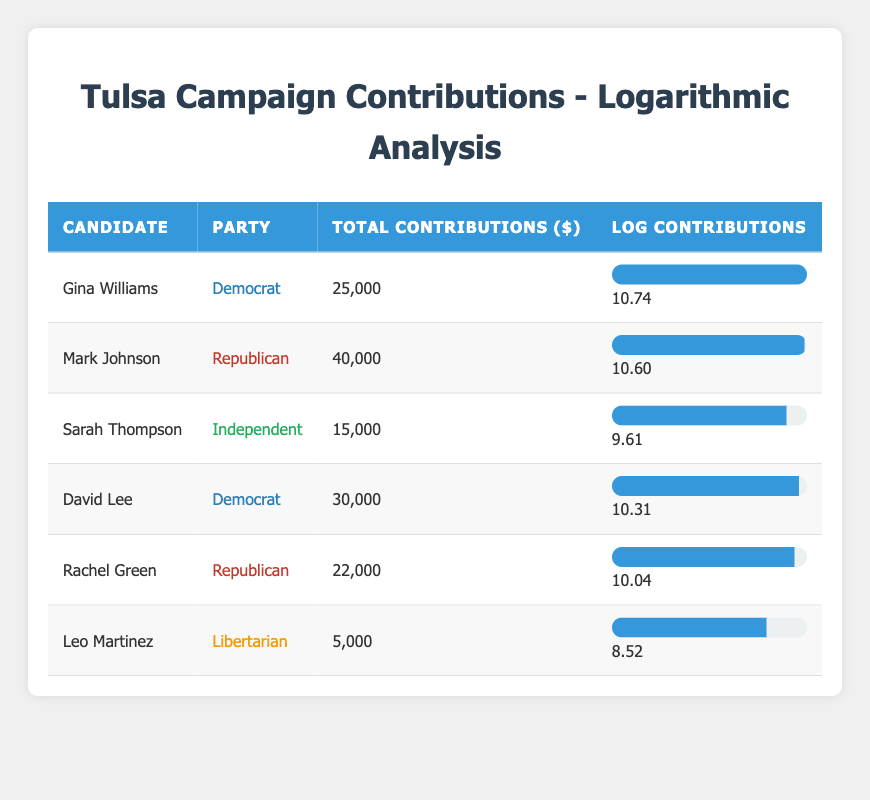What is the total amount of contributions received by Mark Johnson? Mark Johnson received a total of 40,000 in contributions, as indicated in the "Total Contributions ($)" column of the table.
Answer: 40,000 Which candidate received the highest total contributions? The candidate with the highest total contributions is Mark Johnson, with contributions amounting to 40,000. This is the largest figure in the "Total Contributions ($)" column.
Answer: Mark Johnson How many candidates received more than 20,000 in contributions? The candidates who received more than 20,000 in contributions are Mark Johnson (40,000), Gina Williams (25,000), and David Lee (30,000). Counting these entries gives a total of three candidates.
Answer: 3 What is the average total contribution amount for the candidates? To find the average, sum up all total contributions: 25,000 + 40,000 + 15,000 + 30,000 + 22,000 + 5,000 = 137,000. Then divide by the number of candidates (6): 137,000 / 6 = approximately 22,833.33.
Answer: Approximately 22,833.33 Is Sarah Thompson the only Independent candidate listed? Yes, Sarah Thompson is the only candidate listed under the Independent party, as indicated in the "Party" column.
Answer: Yes What is the difference in total contributions between Gina Williams and David Lee? Gina Williams received 25,000 and David Lee received 30,000. The difference is calculated as 30,000 - 25,000 = 5,000.
Answer: 5,000 Which party received the least total contributions among its candidates? From the table, the Libertarian candidate, Leo Martinez, received the least total contributions, adding up to 5,000. No other Libertarian candidates are present.
Answer: Libertarian If we consider candidates who are Democrats, what is their average total contribution? The total contributions for the Democratic candidates are Gina Williams (25,000) and David Lee (30,000). Summing these gives 25,000 + 30,000 = 55,000. Dividing by the number of Democratic candidates (2): 55,000 / 2 = 27,500.
Answer: 27,500 